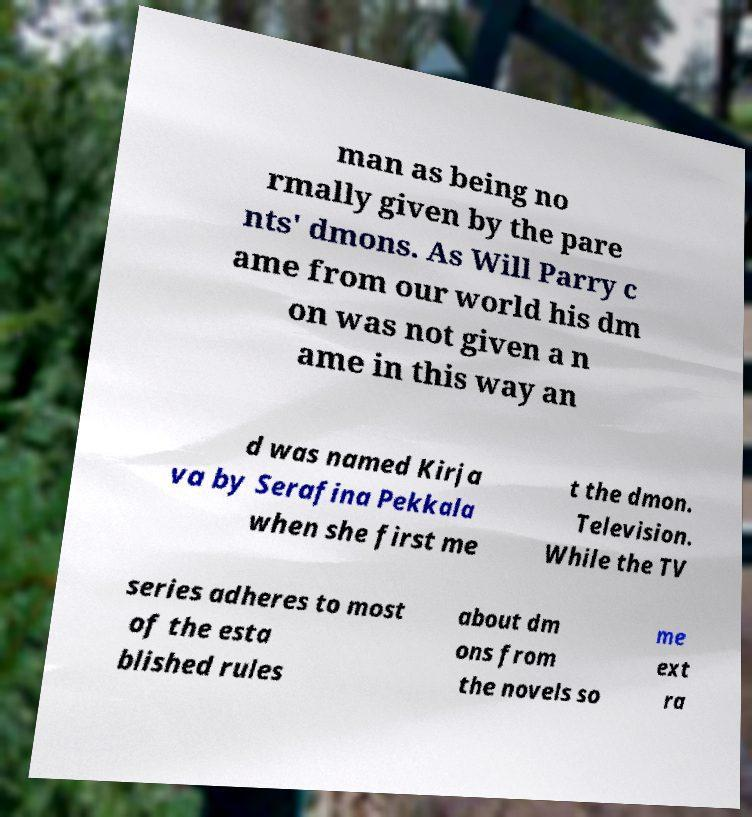Can you read and provide the text displayed in the image?This photo seems to have some interesting text. Can you extract and type it out for me? man as being no rmally given by the pare nts' dmons. As Will Parry c ame from our world his dm on was not given a n ame in this way an d was named Kirja va by Serafina Pekkala when she first me t the dmon. Television. While the TV series adheres to most of the esta blished rules about dm ons from the novels so me ext ra 